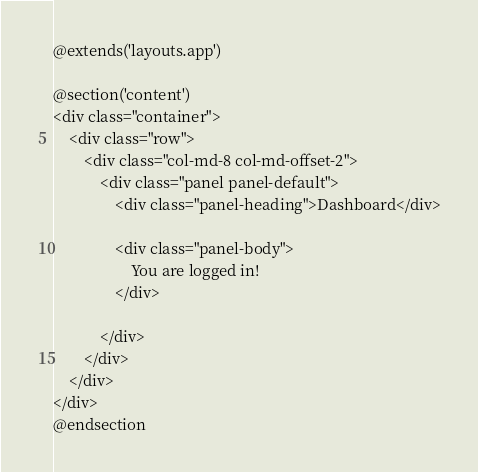<code> <loc_0><loc_0><loc_500><loc_500><_PHP_>@extends('layouts.app')

@section('content')
<div class="container">
    <div class="row">
        <div class="col-md-8 col-md-offset-2">
            <div class="panel panel-default">
                <div class="panel-heading">Dashboard</div>

                <div class="panel-body">
                    You are logged in!
                </div>
                
            </div>
        </div>
    </div>
</div>
@endsection
</code> 